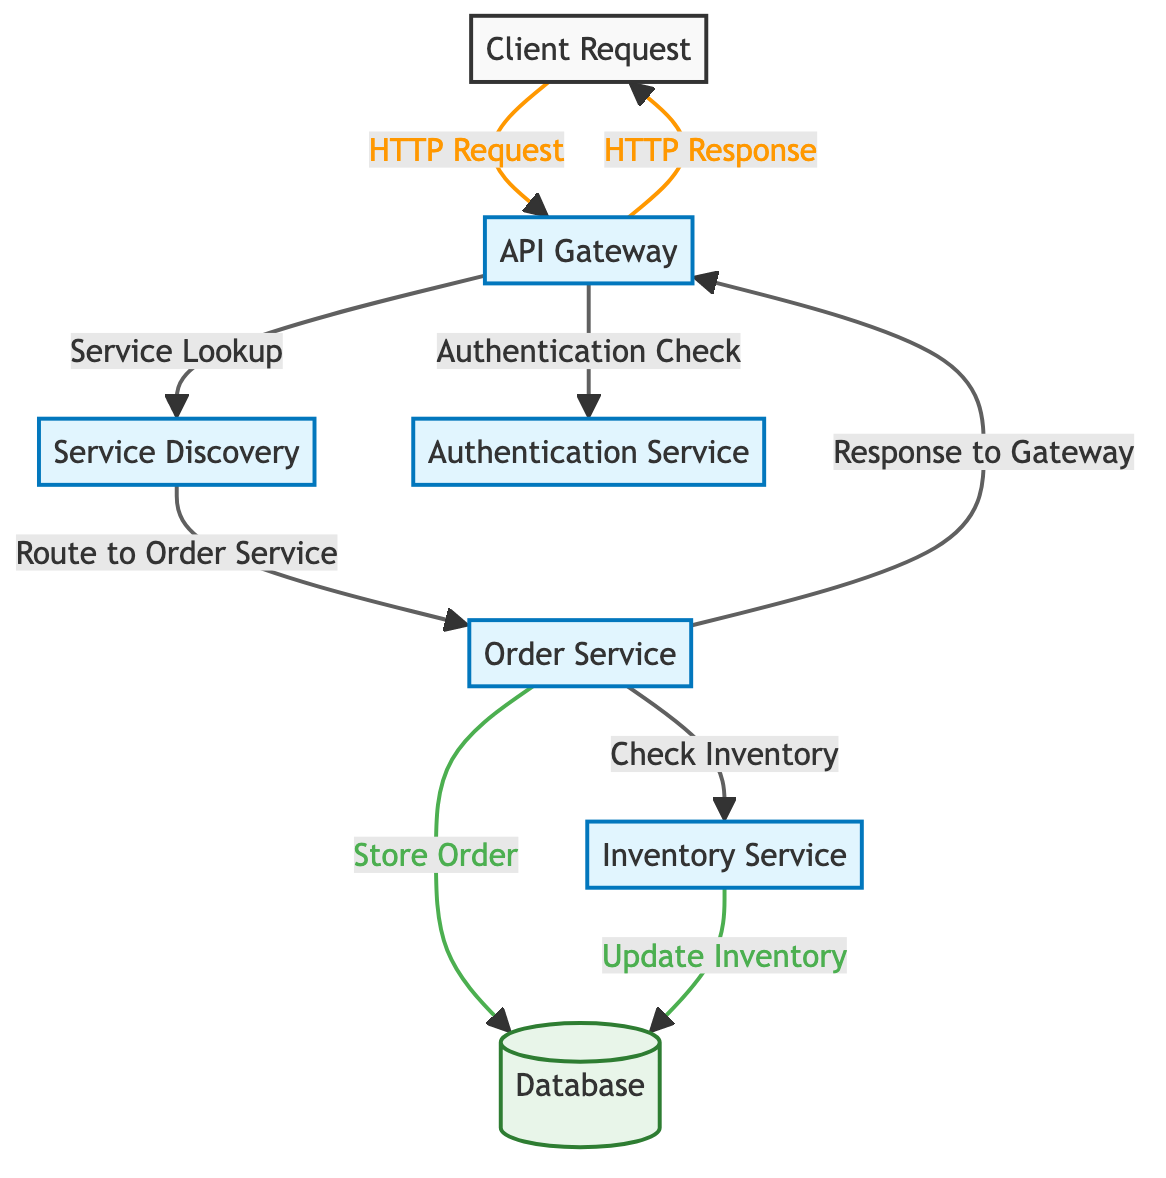What is the starting point of the data flow in this diagram? The data flow begins at the "Client Request." This is the first node from which all subsequent interactions take place.
Answer: Client Request How many service nodes are present in the diagram? By counting the nodes labeled as services, we find five: API Gateway, Service Discovery, Authentication Service, Order Service, and Inventory Service.
Answer: 5 What is the final destination of the data flow in the diagram? The final destination of the data flow is indicated by the "Database," which receives data after all service interactions.
Answer: Database Which service is responsible for checking the inventory? The "Order Service" interacts with the "Inventory Service" to check current inventory levels before processing an order.
Answer: Inventory Service What type of request does the client send to the API Gateway? The client sends an "HTTP Request" to the API Gateway to initiate the flow of data in the system.
Answer: HTTP Request How many different actions does the API Gateway perform in the diagram? The API Gateway performs two actions: it checks authentication and looks up services based on the request.
Answer: 2 What happens after the Order Service processes the order? After processing the order, the Order Service sends a response back to the API Gateway, which then sends it to the client.
Answer: Response to Gateway What type of database interaction occurs after the order is stored? The "Update Inventory" interaction occurs following the order being stored, as the inventory stock needs to reflect the newly processed order.
Answer: Update Inventory Which service is directly linked to the "Database" for storing order details? The "Order Service" is directly linked to the Database for the action of storing order details, indicating data persistence.
Answer: Order Service 